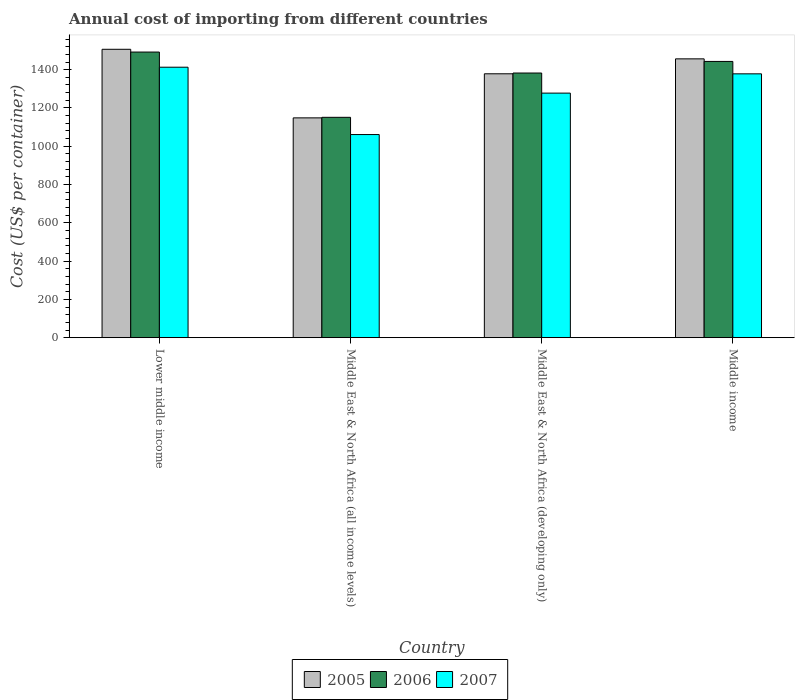How many different coloured bars are there?
Offer a very short reply. 3. Are the number of bars per tick equal to the number of legend labels?
Your answer should be compact. Yes. What is the label of the 1st group of bars from the left?
Your answer should be compact. Lower middle income. In how many cases, is the number of bars for a given country not equal to the number of legend labels?
Provide a short and direct response. 0. What is the total annual cost of importing in 2006 in Middle East & North Africa (developing only)?
Your answer should be very brief. 1382.5. Across all countries, what is the maximum total annual cost of importing in 2006?
Offer a terse response. 1492.04. Across all countries, what is the minimum total annual cost of importing in 2005?
Give a very brief answer. 1148.24. In which country was the total annual cost of importing in 2007 maximum?
Ensure brevity in your answer.  Lower middle income. In which country was the total annual cost of importing in 2005 minimum?
Offer a very short reply. Middle East & North Africa (all income levels). What is the total total annual cost of importing in 2007 in the graph?
Your response must be concise. 5129.51. What is the difference between the total annual cost of importing in 2005 in Middle East & North Africa (all income levels) and that in Middle income?
Offer a very short reply. -308.3. What is the difference between the total annual cost of importing in 2005 in Middle income and the total annual cost of importing in 2007 in Middle East & North Africa (developing only)?
Make the answer very short. 179.03. What is the average total annual cost of importing in 2007 per country?
Your answer should be very brief. 1282.38. What is the difference between the total annual cost of importing of/in 2006 and total annual cost of importing of/in 2005 in Middle income?
Provide a succinct answer. -13.52. In how many countries, is the total annual cost of importing in 2006 greater than 40 US$?
Make the answer very short. 4. What is the ratio of the total annual cost of importing in 2005 in Lower middle income to that in Middle East & North Africa (all income levels)?
Make the answer very short. 1.31. What is the difference between the highest and the second highest total annual cost of importing in 2006?
Provide a short and direct response. -49.03. What is the difference between the highest and the lowest total annual cost of importing in 2007?
Provide a succinct answer. 351.82. In how many countries, is the total annual cost of importing in 2007 greater than the average total annual cost of importing in 2007 taken over all countries?
Keep it short and to the point. 2. What does the 2nd bar from the right in Lower middle income represents?
Your response must be concise. 2006. Is it the case that in every country, the sum of the total annual cost of importing in 2007 and total annual cost of importing in 2006 is greater than the total annual cost of importing in 2005?
Your answer should be compact. Yes. How many bars are there?
Your response must be concise. 12. How many countries are there in the graph?
Your answer should be compact. 4. What is the difference between two consecutive major ticks on the Y-axis?
Provide a short and direct response. 200. Are the values on the major ticks of Y-axis written in scientific E-notation?
Provide a succinct answer. No. Does the graph contain grids?
Provide a short and direct response. No. Where does the legend appear in the graph?
Offer a very short reply. Bottom center. How many legend labels are there?
Provide a succinct answer. 3. What is the title of the graph?
Your response must be concise. Annual cost of importing from different countries. What is the label or title of the X-axis?
Provide a succinct answer. Country. What is the label or title of the Y-axis?
Make the answer very short. Cost (US$ per container). What is the Cost (US$ per container) in 2005 in Lower middle income?
Offer a terse response. 1506.43. What is the Cost (US$ per container) in 2006 in Lower middle income?
Ensure brevity in your answer.  1492.04. What is the Cost (US$ per container) in 2007 in Lower middle income?
Ensure brevity in your answer.  1412.82. What is the Cost (US$ per container) of 2005 in Middle East & North Africa (all income levels)?
Offer a terse response. 1148.24. What is the Cost (US$ per container) in 2006 in Middle East & North Africa (all income levels)?
Provide a succinct answer. 1151.06. What is the Cost (US$ per container) in 2007 in Middle East & North Africa (all income levels)?
Your answer should be very brief. 1061. What is the Cost (US$ per container) in 2005 in Middle East & North Africa (developing only)?
Give a very brief answer. 1378.5. What is the Cost (US$ per container) in 2006 in Middle East & North Africa (developing only)?
Offer a terse response. 1382.5. What is the Cost (US$ per container) of 2007 in Middle East & North Africa (developing only)?
Provide a short and direct response. 1277.5. What is the Cost (US$ per container) in 2005 in Middle income?
Give a very brief answer. 1456.53. What is the Cost (US$ per container) in 2006 in Middle income?
Your answer should be compact. 1443.01. What is the Cost (US$ per container) of 2007 in Middle income?
Your answer should be very brief. 1378.2. Across all countries, what is the maximum Cost (US$ per container) in 2005?
Your answer should be very brief. 1506.43. Across all countries, what is the maximum Cost (US$ per container) of 2006?
Your answer should be compact. 1492.04. Across all countries, what is the maximum Cost (US$ per container) in 2007?
Your answer should be compact. 1412.82. Across all countries, what is the minimum Cost (US$ per container) in 2005?
Offer a terse response. 1148.24. Across all countries, what is the minimum Cost (US$ per container) of 2006?
Provide a succinct answer. 1151.06. Across all countries, what is the minimum Cost (US$ per container) of 2007?
Offer a very short reply. 1061. What is the total Cost (US$ per container) of 2005 in the graph?
Your answer should be very brief. 5489.7. What is the total Cost (US$ per container) in 2006 in the graph?
Offer a very short reply. 5468.61. What is the total Cost (US$ per container) in 2007 in the graph?
Your response must be concise. 5129.51. What is the difference between the Cost (US$ per container) of 2005 in Lower middle income and that in Middle East & North Africa (all income levels)?
Offer a very short reply. 358.19. What is the difference between the Cost (US$ per container) of 2006 in Lower middle income and that in Middle East & North Africa (all income levels)?
Provide a succinct answer. 340.98. What is the difference between the Cost (US$ per container) in 2007 in Lower middle income and that in Middle East & North Africa (all income levels)?
Your answer should be very brief. 351.82. What is the difference between the Cost (US$ per container) in 2005 in Lower middle income and that in Middle East & North Africa (developing only)?
Give a very brief answer. 127.93. What is the difference between the Cost (US$ per container) of 2006 in Lower middle income and that in Middle East & North Africa (developing only)?
Make the answer very short. 109.54. What is the difference between the Cost (US$ per container) in 2007 in Lower middle income and that in Middle East & North Africa (developing only)?
Ensure brevity in your answer.  135.32. What is the difference between the Cost (US$ per container) of 2005 in Lower middle income and that in Middle income?
Make the answer very short. 49.9. What is the difference between the Cost (US$ per container) in 2006 in Lower middle income and that in Middle income?
Make the answer very short. 49.03. What is the difference between the Cost (US$ per container) in 2007 in Lower middle income and that in Middle income?
Offer a very short reply. 34.62. What is the difference between the Cost (US$ per container) in 2005 in Middle East & North Africa (all income levels) and that in Middle East & North Africa (developing only)?
Your answer should be compact. -230.26. What is the difference between the Cost (US$ per container) of 2006 in Middle East & North Africa (all income levels) and that in Middle East & North Africa (developing only)?
Offer a very short reply. -231.44. What is the difference between the Cost (US$ per container) in 2007 in Middle East & North Africa (all income levels) and that in Middle East & North Africa (developing only)?
Ensure brevity in your answer.  -216.5. What is the difference between the Cost (US$ per container) of 2005 in Middle East & North Africa (all income levels) and that in Middle income?
Provide a succinct answer. -308.3. What is the difference between the Cost (US$ per container) in 2006 in Middle East & North Africa (all income levels) and that in Middle income?
Your answer should be very brief. -291.95. What is the difference between the Cost (US$ per container) in 2007 in Middle East & North Africa (all income levels) and that in Middle income?
Ensure brevity in your answer.  -317.2. What is the difference between the Cost (US$ per container) in 2005 in Middle East & North Africa (developing only) and that in Middle income?
Keep it short and to the point. -78.03. What is the difference between the Cost (US$ per container) in 2006 in Middle East & North Africa (developing only) and that in Middle income?
Ensure brevity in your answer.  -60.51. What is the difference between the Cost (US$ per container) in 2007 in Middle East & North Africa (developing only) and that in Middle income?
Ensure brevity in your answer.  -100.7. What is the difference between the Cost (US$ per container) in 2005 in Lower middle income and the Cost (US$ per container) in 2006 in Middle East & North Africa (all income levels)?
Ensure brevity in your answer.  355.37. What is the difference between the Cost (US$ per container) of 2005 in Lower middle income and the Cost (US$ per container) of 2007 in Middle East & North Africa (all income levels)?
Provide a short and direct response. 445.43. What is the difference between the Cost (US$ per container) in 2006 in Lower middle income and the Cost (US$ per container) in 2007 in Middle East & North Africa (all income levels)?
Ensure brevity in your answer.  431.04. What is the difference between the Cost (US$ per container) of 2005 in Lower middle income and the Cost (US$ per container) of 2006 in Middle East & North Africa (developing only)?
Provide a succinct answer. 123.93. What is the difference between the Cost (US$ per container) in 2005 in Lower middle income and the Cost (US$ per container) in 2007 in Middle East & North Africa (developing only)?
Your answer should be very brief. 228.93. What is the difference between the Cost (US$ per container) of 2006 in Lower middle income and the Cost (US$ per container) of 2007 in Middle East & North Africa (developing only)?
Offer a very short reply. 214.54. What is the difference between the Cost (US$ per container) in 2005 in Lower middle income and the Cost (US$ per container) in 2006 in Middle income?
Make the answer very short. 63.42. What is the difference between the Cost (US$ per container) of 2005 in Lower middle income and the Cost (US$ per container) of 2007 in Middle income?
Your response must be concise. 128.23. What is the difference between the Cost (US$ per container) in 2006 in Lower middle income and the Cost (US$ per container) in 2007 in Middle income?
Your response must be concise. 113.84. What is the difference between the Cost (US$ per container) in 2005 in Middle East & North Africa (all income levels) and the Cost (US$ per container) in 2006 in Middle East & North Africa (developing only)?
Offer a terse response. -234.26. What is the difference between the Cost (US$ per container) in 2005 in Middle East & North Africa (all income levels) and the Cost (US$ per container) in 2007 in Middle East & North Africa (developing only)?
Your response must be concise. -129.26. What is the difference between the Cost (US$ per container) in 2006 in Middle East & North Africa (all income levels) and the Cost (US$ per container) in 2007 in Middle East & North Africa (developing only)?
Provide a short and direct response. -126.44. What is the difference between the Cost (US$ per container) of 2005 in Middle East & North Africa (all income levels) and the Cost (US$ per container) of 2006 in Middle income?
Provide a short and direct response. -294.77. What is the difference between the Cost (US$ per container) in 2005 in Middle East & North Africa (all income levels) and the Cost (US$ per container) in 2007 in Middle income?
Make the answer very short. -229.96. What is the difference between the Cost (US$ per container) of 2006 in Middle East & North Africa (all income levels) and the Cost (US$ per container) of 2007 in Middle income?
Give a very brief answer. -227.14. What is the difference between the Cost (US$ per container) of 2005 in Middle East & North Africa (developing only) and the Cost (US$ per container) of 2006 in Middle income?
Your response must be concise. -64.51. What is the difference between the Cost (US$ per container) in 2005 in Middle East & North Africa (developing only) and the Cost (US$ per container) in 2007 in Middle income?
Ensure brevity in your answer.  0.3. What is the difference between the Cost (US$ per container) in 2006 in Middle East & North Africa (developing only) and the Cost (US$ per container) in 2007 in Middle income?
Your answer should be very brief. 4.3. What is the average Cost (US$ per container) in 2005 per country?
Your response must be concise. 1372.42. What is the average Cost (US$ per container) of 2006 per country?
Your answer should be compact. 1367.15. What is the average Cost (US$ per container) in 2007 per country?
Keep it short and to the point. 1282.38. What is the difference between the Cost (US$ per container) of 2005 and Cost (US$ per container) of 2006 in Lower middle income?
Offer a very short reply. 14.39. What is the difference between the Cost (US$ per container) in 2005 and Cost (US$ per container) in 2007 in Lower middle income?
Make the answer very short. 93.61. What is the difference between the Cost (US$ per container) of 2006 and Cost (US$ per container) of 2007 in Lower middle income?
Provide a succinct answer. 79.22. What is the difference between the Cost (US$ per container) in 2005 and Cost (US$ per container) in 2006 in Middle East & North Africa (all income levels)?
Ensure brevity in your answer.  -2.82. What is the difference between the Cost (US$ per container) of 2005 and Cost (US$ per container) of 2007 in Middle East & North Africa (all income levels)?
Provide a succinct answer. 87.24. What is the difference between the Cost (US$ per container) in 2006 and Cost (US$ per container) in 2007 in Middle East & North Africa (all income levels)?
Your answer should be very brief. 90.06. What is the difference between the Cost (US$ per container) in 2005 and Cost (US$ per container) in 2006 in Middle East & North Africa (developing only)?
Ensure brevity in your answer.  -4. What is the difference between the Cost (US$ per container) in 2005 and Cost (US$ per container) in 2007 in Middle East & North Africa (developing only)?
Your answer should be compact. 101. What is the difference between the Cost (US$ per container) of 2006 and Cost (US$ per container) of 2007 in Middle East & North Africa (developing only)?
Your answer should be very brief. 105. What is the difference between the Cost (US$ per container) in 2005 and Cost (US$ per container) in 2006 in Middle income?
Give a very brief answer. 13.52. What is the difference between the Cost (US$ per container) of 2005 and Cost (US$ per container) of 2007 in Middle income?
Offer a very short reply. 78.34. What is the difference between the Cost (US$ per container) in 2006 and Cost (US$ per container) in 2007 in Middle income?
Offer a terse response. 64.81. What is the ratio of the Cost (US$ per container) of 2005 in Lower middle income to that in Middle East & North Africa (all income levels)?
Your answer should be compact. 1.31. What is the ratio of the Cost (US$ per container) in 2006 in Lower middle income to that in Middle East & North Africa (all income levels)?
Offer a terse response. 1.3. What is the ratio of the Cost (US$ per container) in 2007 in Lower middle income to that in Middle East & North Africa (all income levels)?
Give a very brief answer. 1.33. What is the ratio of the Cost (US$ per container) of 2005 in Lower middle income to that in Middle East & North Africa (developing only)?
Your response must be concise. 1.09. What is the ratio of the Cost (US$ per container) in 2006 in Lower middle income to that in Middle East & North Africa (developing only)?
Give a very brief answer. 1.08. What is the ratio of the Cost (US$ per container) in 2007 in Lower middle income to that in Middle East & North Africa (developing only)?
Provide a succinct answer. 1.11. What is the ratio of the Cost (US$ per container) in 2005 in Lower middle income to that in Middle income?
Your response must be concise. 1.03. What is the ratio of the Cost (US$ per container) in 2006 in Lower middle income to that in Middle income?
Provide a short and direct response. 1.03. What is the ratio of the Cost (US$ per container) of 2007 in Lower middle income to that in Middle income?
Provide a short and direct response. 1.03. What is the ratio of the Cost (US$ per container) in 2005 in Middle East & North Africa (all income levels) to that in Middle East & North Africa (developing only)?
Give a very brief answer. 0.83. What is the ratio of the Cost (US$ per container) of 2006 in Middle East & North Africa (all income levels) to that in Middle East & North Africa (developing only)?
Provide a succinct answer. 0.83. What is the ratio of the Cost (US$ per container) in 2007 in Middle East & North Africa (all income levels) to that in Middle East & North Africa (developing only)?
Make the answer very short. 0.83. What is the ratio of the Cost (US$ per container) of 2005 in Middle East & North Africa (all income levels) to that in Middle income?
Offer a very short reply. 0.79. What is the ratio of the Cost (US$ per container) in 2006 in Middle East & North Africa (all income levels) to that in Middle income?
Your answer should be compact. 0.8. What is the ratio of the Cost (US$ per container) of 2007 in Middle East & North Africa (all income levels) to that in Middle income?
Your answer should be compact. 0.77. What is the ratio of the Cost (US$ per container) in 2005 in Middle East & North Africa (developing only) to that in Middle income?
Keep it short and to the point. 0.95. What is the ratio of the Cost (US$ per container) of 2006 in Middle East & North Africa (developing only) to that in Middle income?
Ensure brevity in your answer.  0.96. What is the ratio of the Cost (US$ per container) in 2007 in Middle East & North Africa (developing only) to that in Middle income?
Ensure brevity in your answer.  0.93. What is the difference between the highest and the second highest Cost (US$ per container) of 2005?
Make the answer very short. 49.9. What is the difference between the highest and the second highest Cost (US$ per container) in 2006?
Provide a short and direct response. 49.03. What is the difference between the highest and the second highest Cost (US$ per container) of 2007?
Offer a terse response. 34.62. What is the difference between the highest and the lowest Cost (US$ per container) in 2005?
Your answer should be very brief. 358.19. What is the difference between the highest and the lowest Cost (US$ per container) in 2006?
Offer a terse response. 340.98. What is the difference between the highest and the lowest Cost (US$ per container) in 2007?
Your answer should be compact. 351.82. 